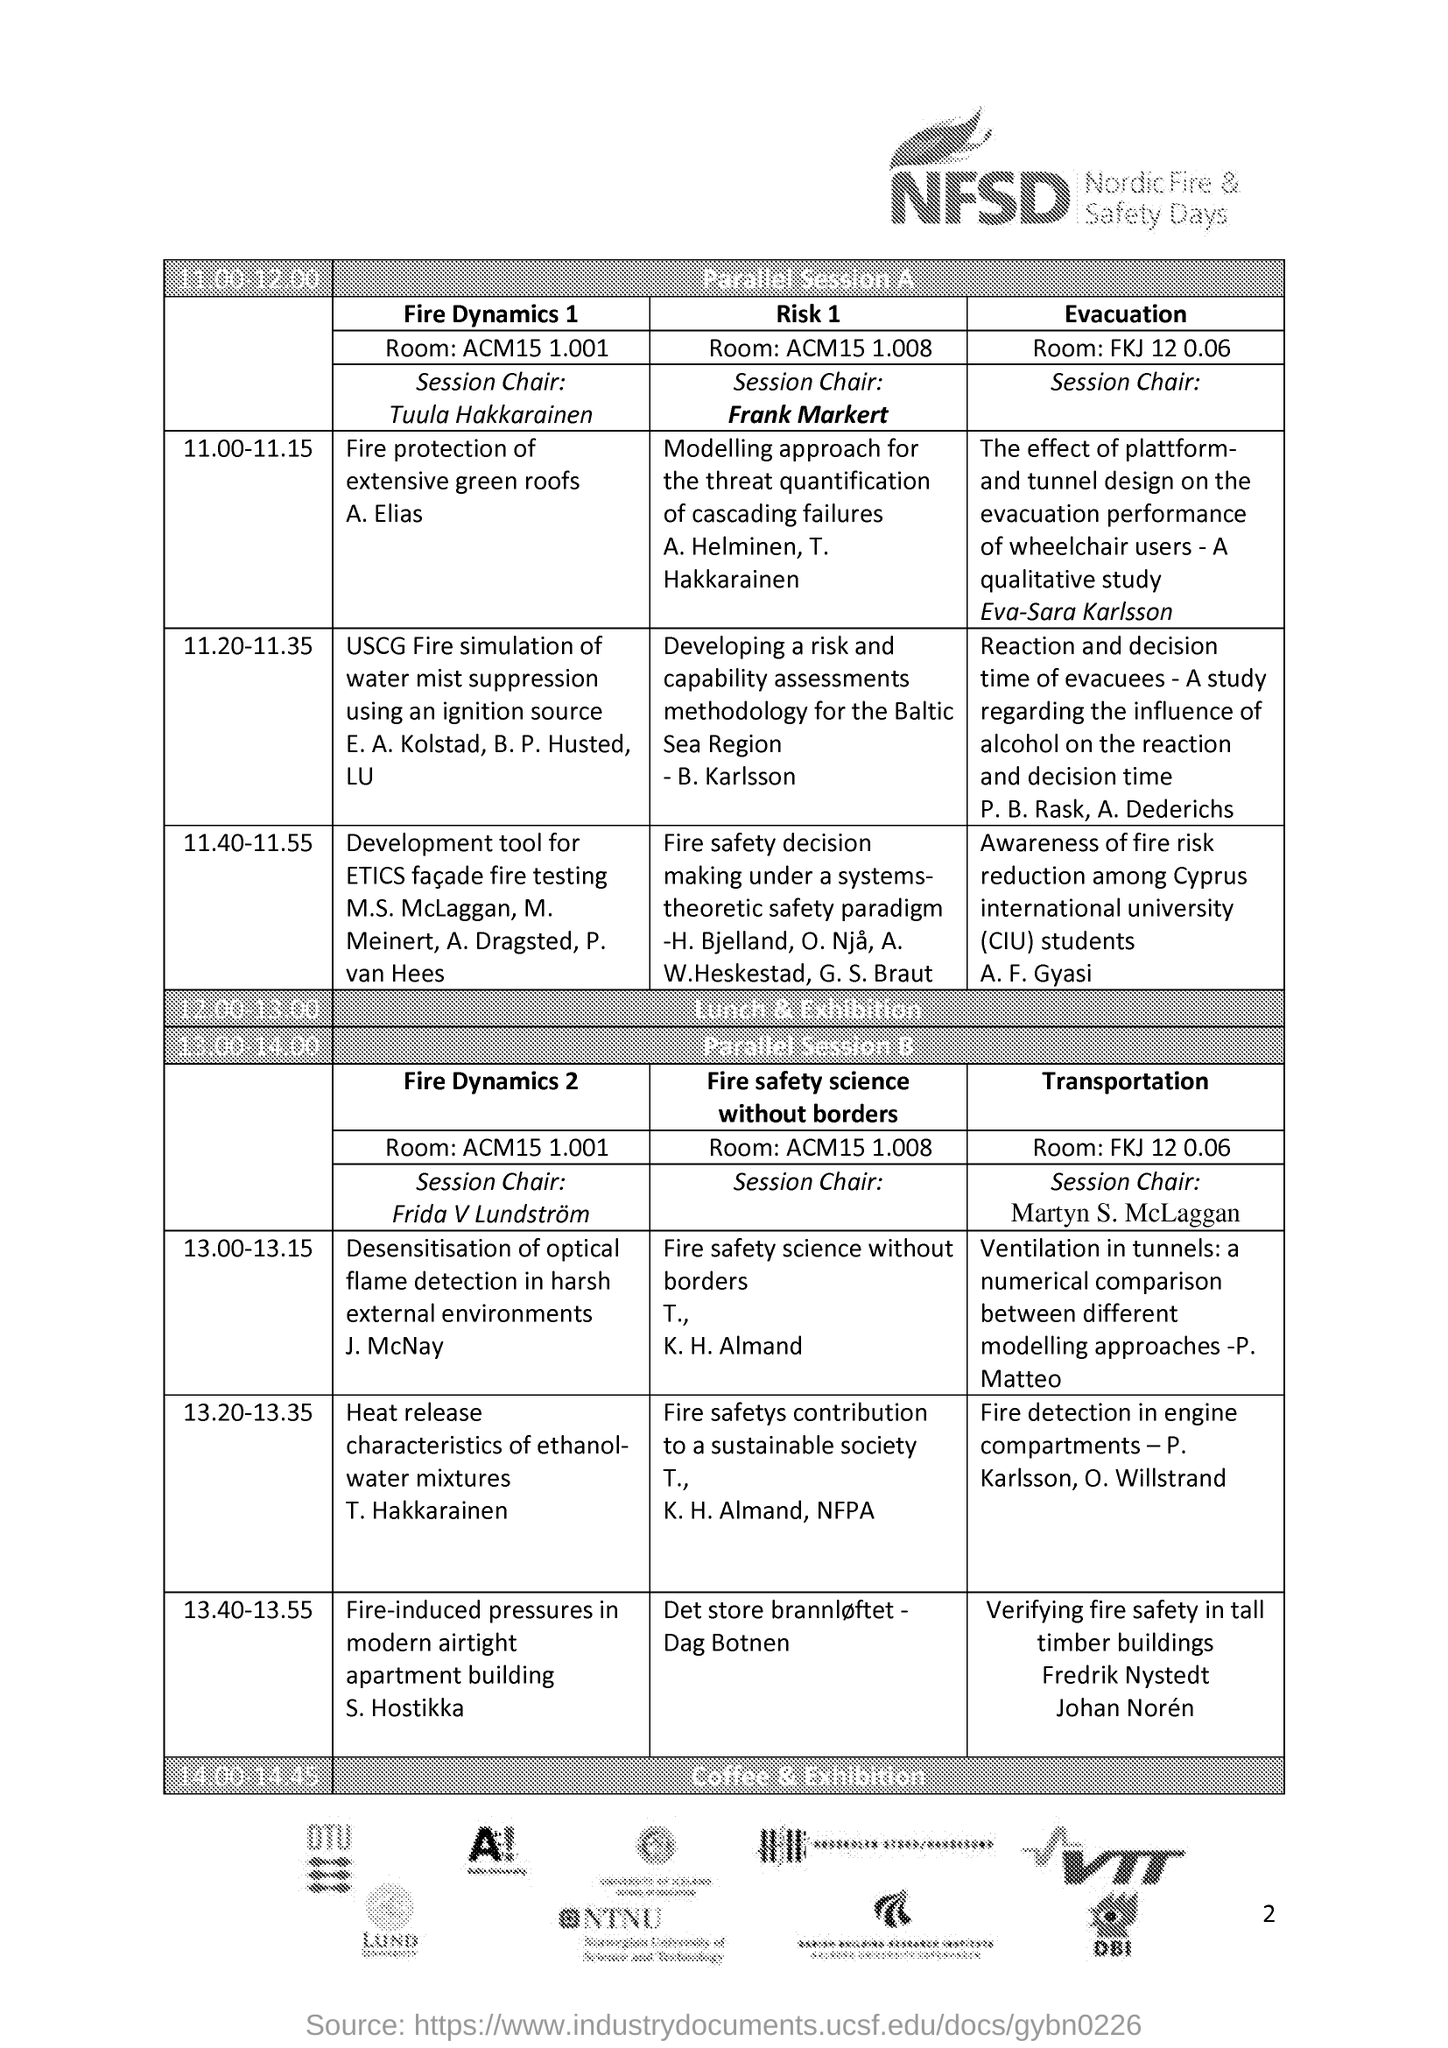Give some essential details in this illustration. The fire-induced pressures in modern airtight apartment buildings were discussed during a parallel session by S. Hostikka. The session chair for 'Fire Dynamics 2' is Frida V Lundstrom. The session on 'Fire protection of extensive green roofs' is being presented by Elias. The session chair for "Risk 1" is Frank Markert. Nordic Fire & Safety Days is an acronym that is commonly referred to as NFSD. 